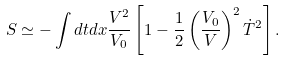Convert formula to latex. <formula><loc_0><loc_0><loc_500><loc_500>S \simeq - \int d t d x \frac { V ^ { 2 } } { V _ { 0 } } \left [ 1 - \frac { 1 } { 2 } \left ( \frac { V _ { 0 } } { V } \right ) ^ { 2 } \dot { T } ^ { 2 } \right ] .</formula> 